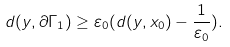Convert formula to latex. <formula><loc_0><loc_0><loc_500><loc_500>d ( y , \partial \Gamma _ { 1 } ) \geq \varepsilon _ { 0 } ( d ( y , x _ { 0 } ) - \frac { 1 } { \varepsilon _ { 0 } } ) .</formula> 